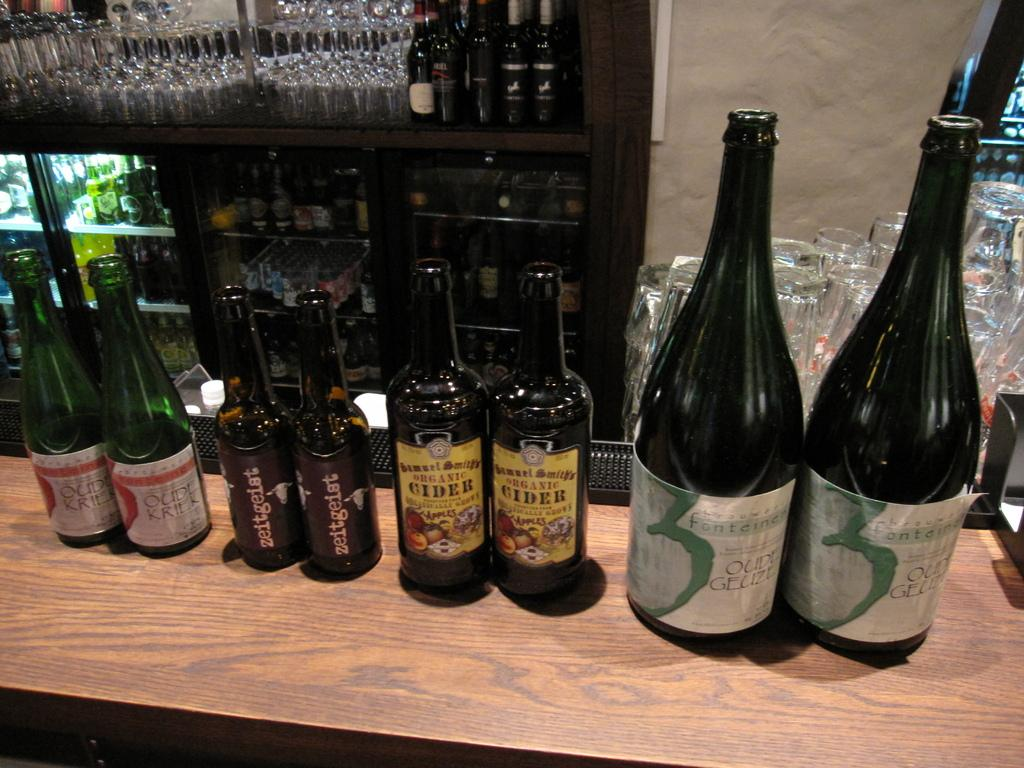<image>
Render a clear and concise summary of the photo. Two bottle of cider sit on a bar top among other paired bottles of alcohol. 